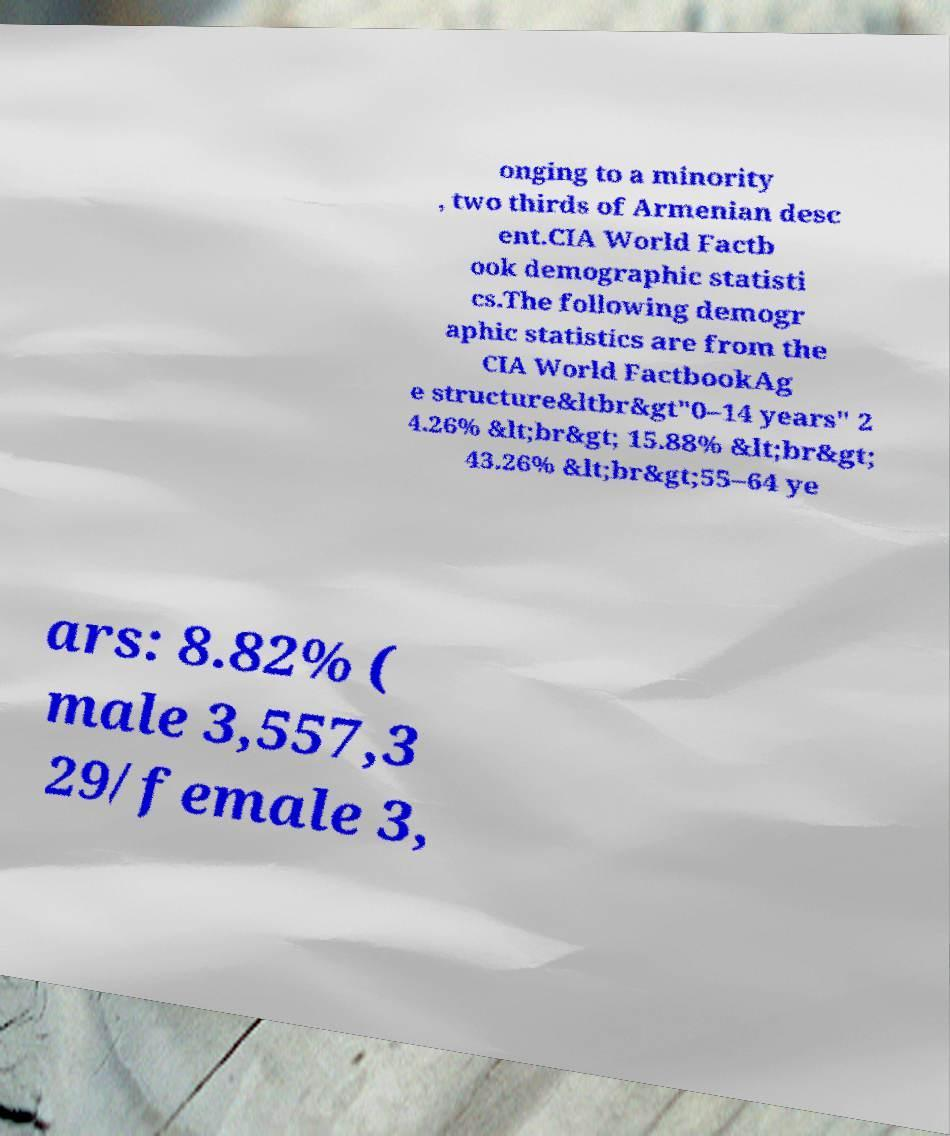Could you assist in decoding the text presented in this image and type it out clearly? onging to a minority , two thirds of Armenian desc ent.CIA World Factb ook demographic statisti cs.The following demogr aphic statistics are from the CIA World FactbookAg e structure&ltbr&gt"0–14 years" 2 4.26% &lt;br&gt; 15.88% &lt;br&gt; 43.26% &lt;br&gt;55–64 ye ars: 8.82% ( male 3,557,3 29/female 3, 